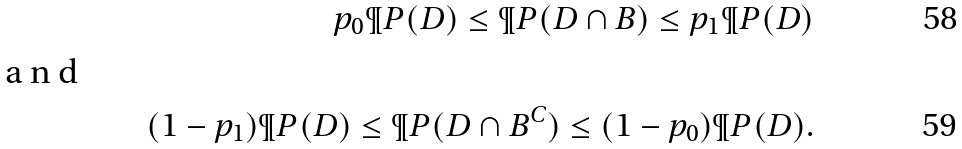Convert formula to latex. <formula><loc_0><loc_0><loc_500><loc_500>p _ { 0 } \P P ( D ) \leq \P P ( D \cap B ) \leq p _ { 1 } \P P ( D ) \\ \intertext { a n d } ( 1 - p _ { 1 } ) \P P ( D ) \leq \P P ( D \cap B ^ { C } ) \leq ( 1 - p _ { 0 } ) \P P ( D ) .</formula> 